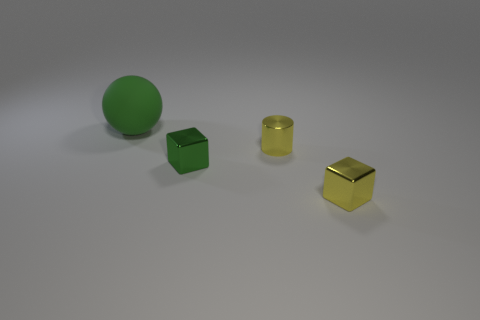Add 3 large matte balls. How many objects exist? 7 Subtract all balls. How many objects are left? 3 Subtract 1 green balls. How many objects are left? 3 Subtract all green metal blocks. Subtract all green shiny spheres. How many objects are left? 3 Add 4 yellow objects. How many yellow objects are left? 6 Add 2 large green spheres. How many large green spheres exist? 3 